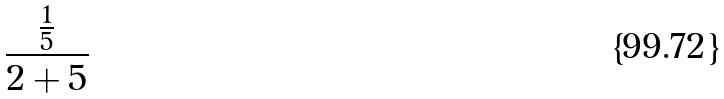<formula> <loc_0><loc_0><loc_500><loc_500>\frac { \frac { 1 } { 5 } } { 2 + 5 }</formula> 